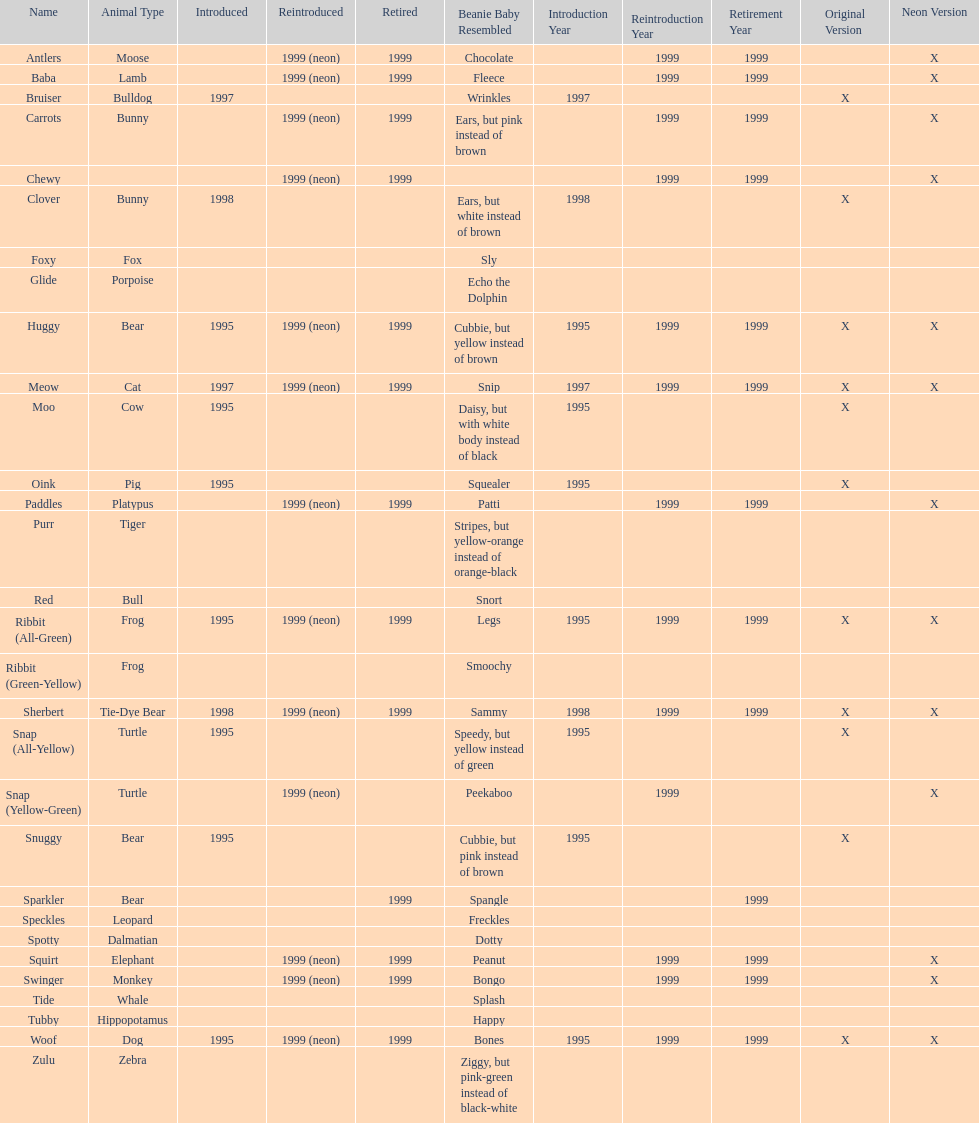What are the total number of pillow pals on this chart? 30. 